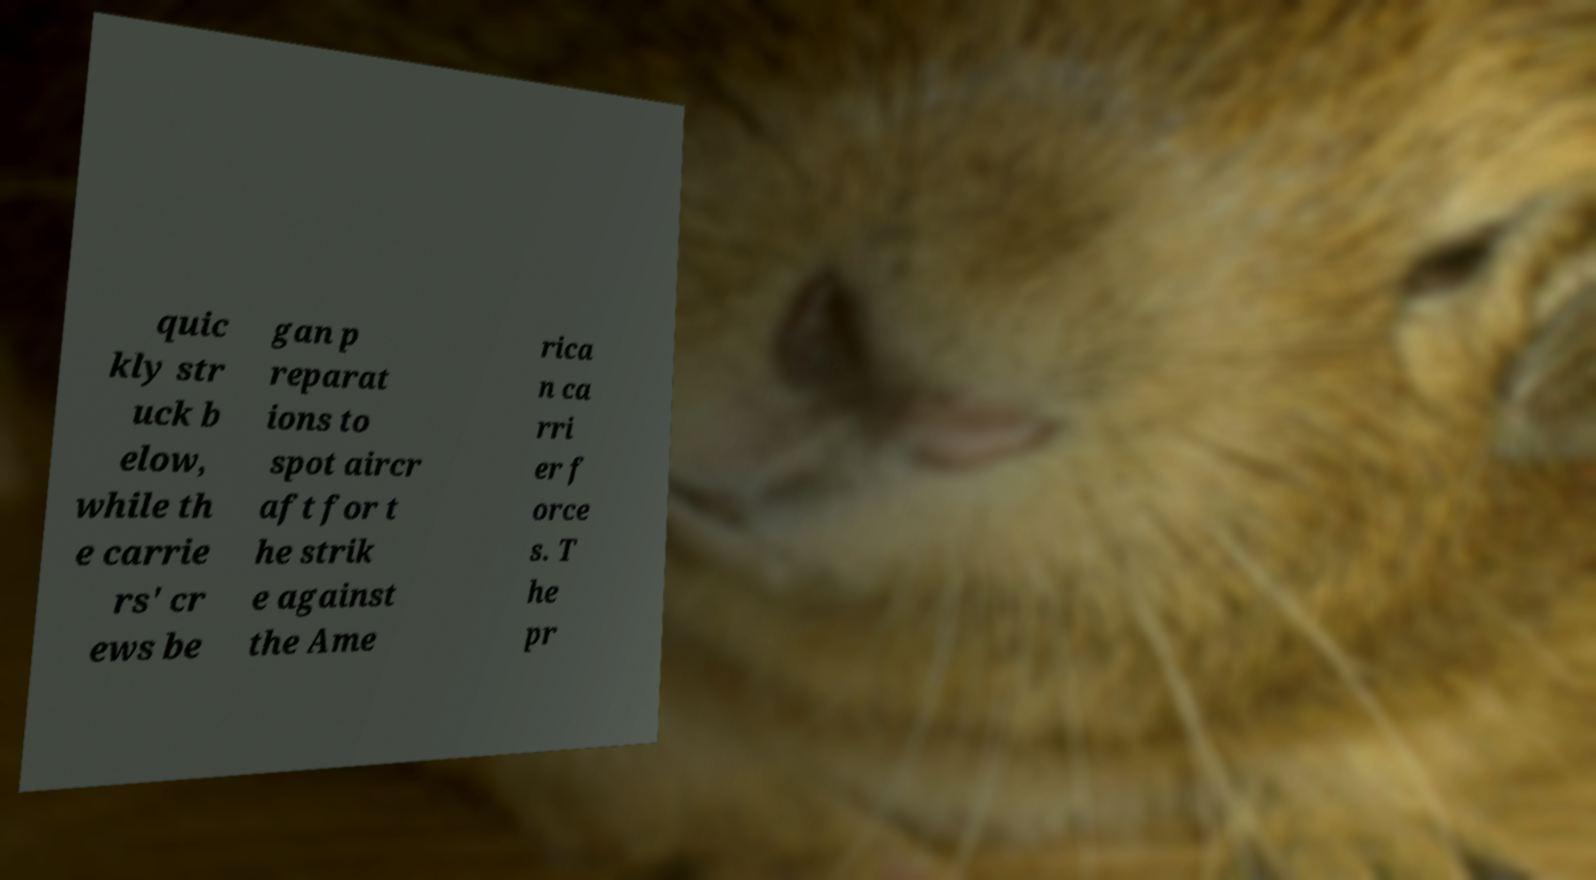I need the written content from this picture converted into text. Can you do that? quic kly str uck b elow, while th e carrie rs' cr ews be gan p reparat ions to spot aircr aft for t he strik e against the Ame rica n ca rri er f orce s. T he pr 